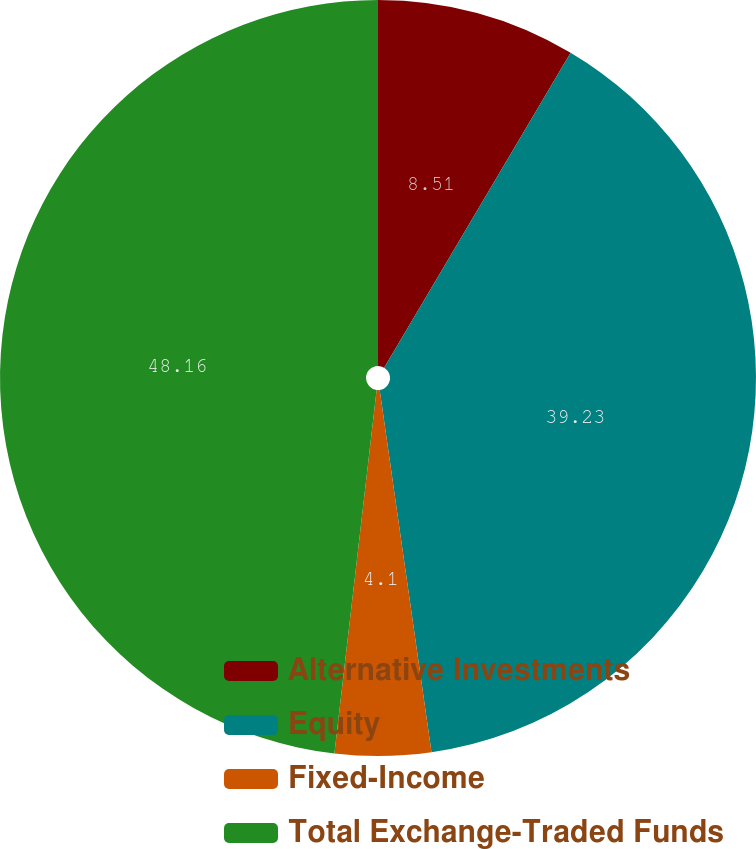Convert chart. <chart><loc_0><loc_0><loc_500><loc_500><pie_chart><fcel>Alternative Investments<fcel>Equity<fcel>Fixed-Income<fcel>Total Exchange-Traded Funds<nl><fcel>8.51%<fcel>39.23%<fcel>4.1%<fcel>48.16%<nl></chart> 